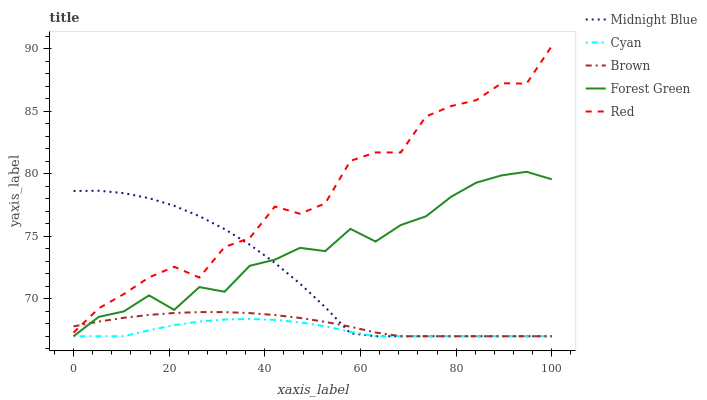Does Forest Green have the minimum area under the curve?
Answer yes or no. No. Does Forest Green have the maximum area under the curve?
Answer yes or no. No. Is Forest Green the smoothest?
Answer yes or no. No. Is Forest Green the roughest?
Answer yes or no. No. Does Red have the lowest value?
Answer yes or no. No. Does Forest Green have the highest value?
Answer yes or no. No. Is Cyan less than Red?
Answer yes or no. Yes. Is Red greater than Cyan?
Answer yes or no. Yes. Does Cyan intersect Red?
Answer yes or no. No. 